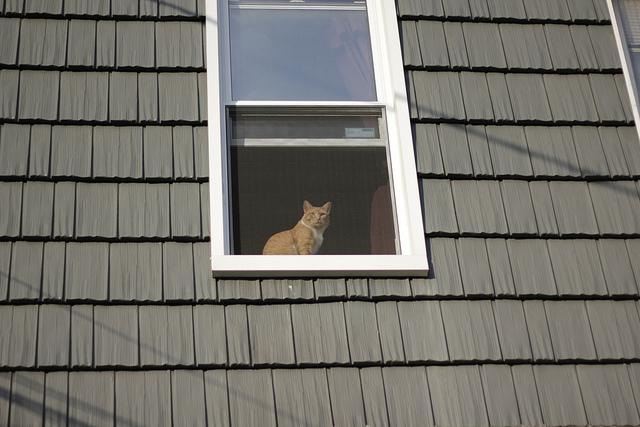Is the light on inside?
Be succinct. No. Is the window open or closed?
Be succinct. Open. What is the building made out of?
Answer briefly. Wood. What is looking out of the open window?
Concise answer only. Cat. Is this a first floor window?
Give a very brief answer. No. What is in the window?
Keep it brief. Cat. 